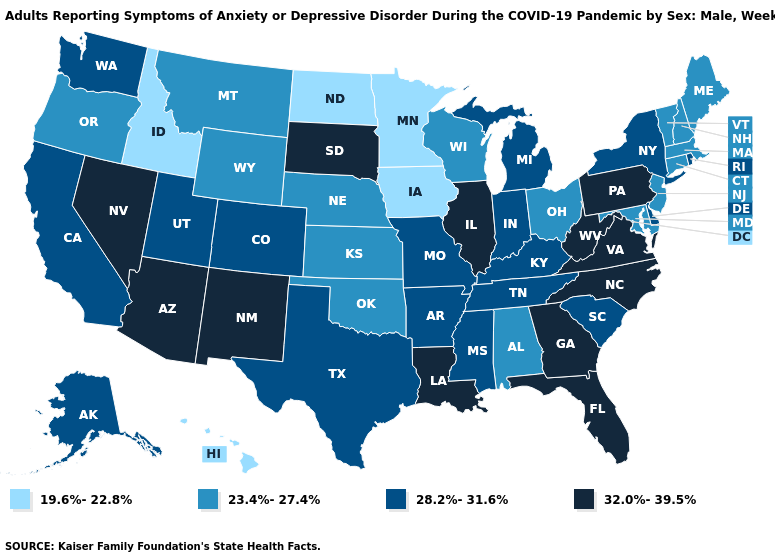Name the states that have a value in the range 23.4%-27.4%?
Concise answer only. Alabama, Connecticut, Kansas, Maine, Maryland, Massachusetts, Montana, Nebraska, New Hampshire, New Jersey, Ohio, Oklahoma, Oregon, Vermont, Wisconsin, Wyoming. Does Wyoming have the highest value in the USA?
Give a very brief answer. No. Does New Jersey have a higher value than Connecticut?
Keep it brief. No. Which states have the lowest value in the USA?
Write a very short answer. Hawaii, Idaho, Iowa, Minnesota, North Dakota. Does North Dakota have the lowest value in the USA?
Answer briefly. Yes. Which states have the lowest value in the USA?
Keep it brief. Hawaii, Idaho, Iowa, Minnesota, North Dakota. What is the value of Iowa?
Short answer required. 19.6%-22.8%. Does West Virginia have a higher value than Georgia?
Keep it brief. No. What is the value of Utah?
Write a very short answer. 28.2%-31.6%. What is the value of Alaska?
Write a very short answer. 28.2%-31.6%. What is the highest value in the USA?
Keep it brief. 32.0%-39.5%. Does the map have missing data?
Write a very short answer. No. Does the map have missing data?
Quick response, please. No. Which states have the highest value in the USA?
Keep it brief. Arizona, Florida, Georgia, Illinois, Louisiana, Nevada, New Mexico, North Carolina, Pennsylvania, South Dakota, Virginia, West Virginia. Name the states that have a value in the range 28.2%-31.6%?
Be succinct. Alaska, Arkansas, California, Colorado, Delaware, Indiana, Kentucky, Michigan, Mississippi, Missouri, New York, Rhode Island, South Carolina, Tennessee, Texas, Utah, Washington. 